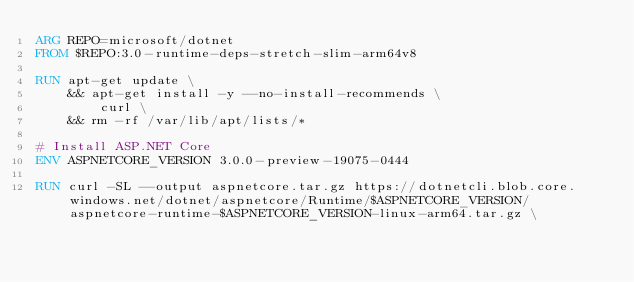<code> <loc_0><loc_0><loc_500><loc_500><_Dockerfile_>ARG REPO=microsoft/dotnet
FROM $REPO:3.0-runtime-deps-stretch-slim-arm64v8

RUN apt-get update \
    && apt-get install -y --no-install-recommends \
        curl \
    && rm -rf /var/lib/apt/lists/*

# Install ASP.NET Core
ENV ASPNETCORE_VERSION 3.0.0-preview-19075-0444

RUN curl -SL --output aspnetcore.tar.gz https://dotnetcli.blob.core.windows.net/dotnet/aspnetcore/Runtime/$ASPNETCORE_VERSION/aspnetcore-runtime-$ASPNETCORE_VERSION-linux-arm64.tar.gz \</code> 